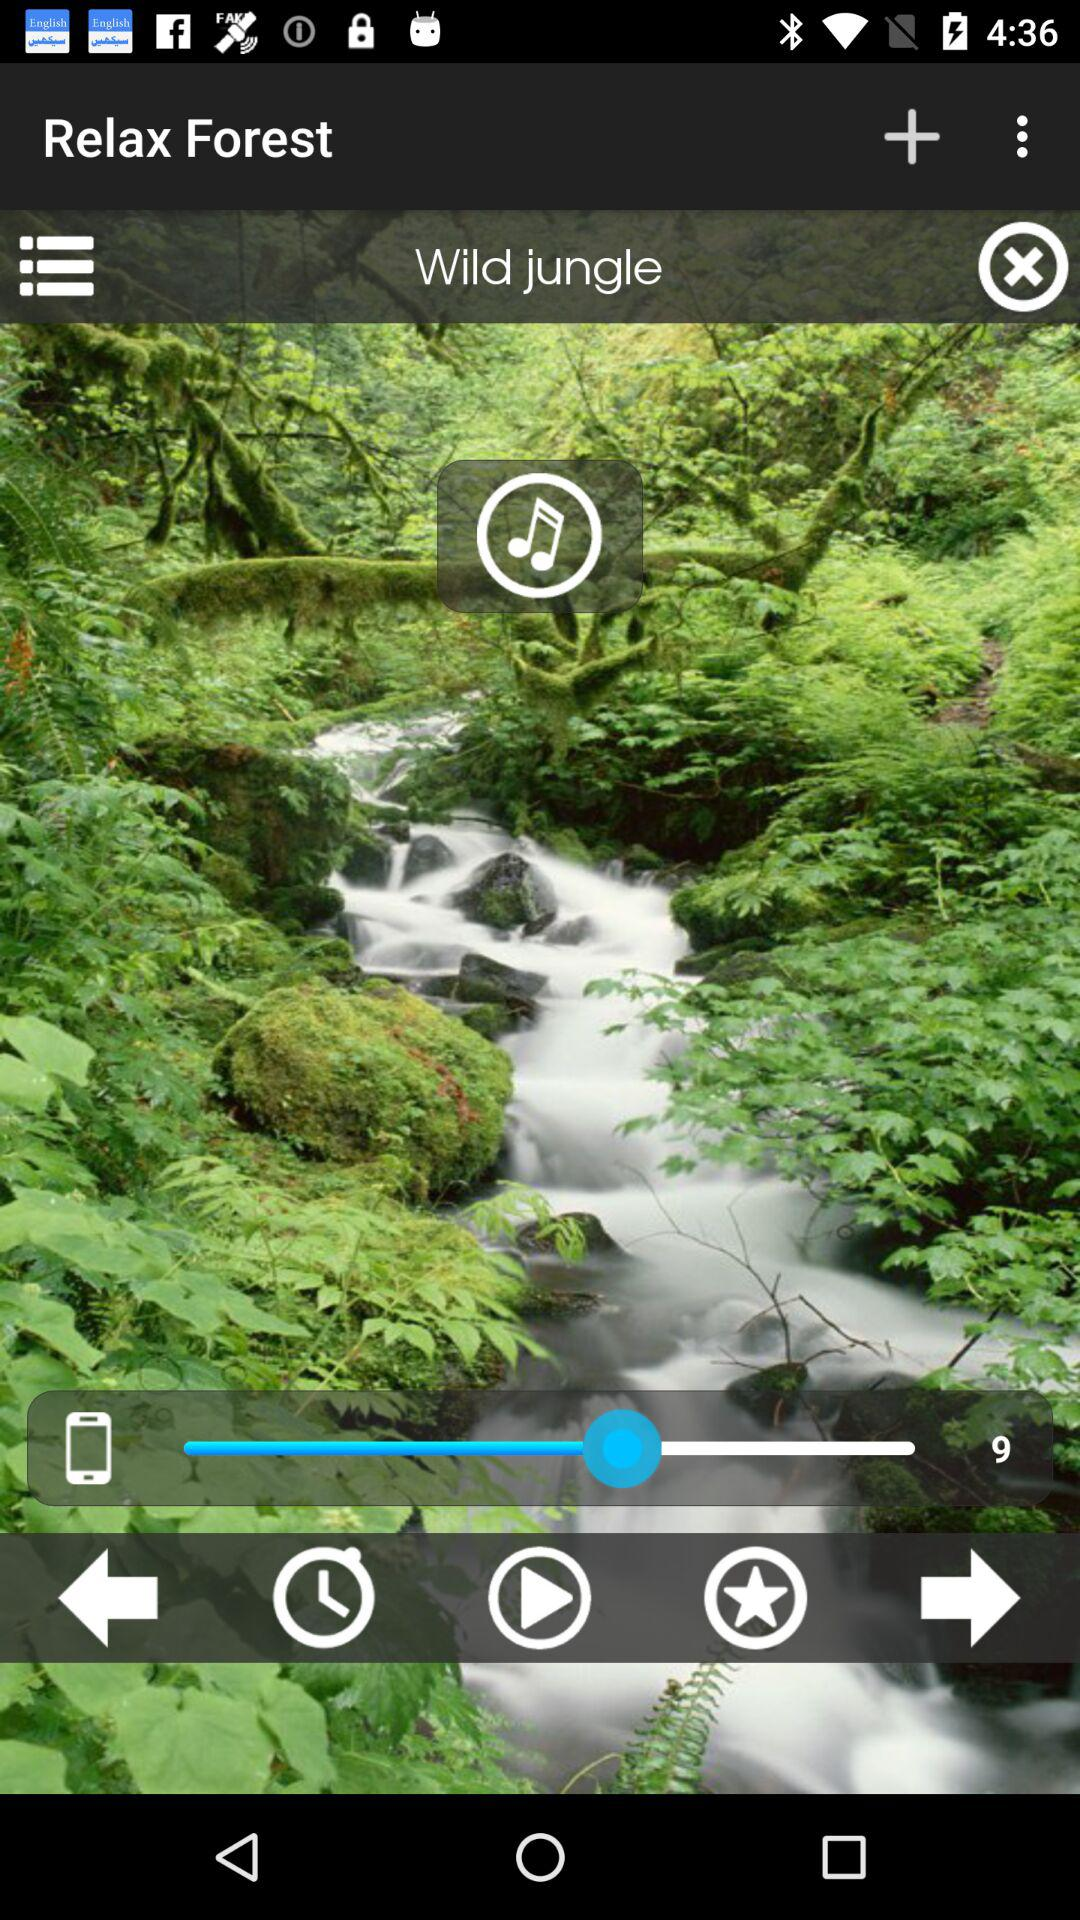What is the name of the music? The name of the music is "Wild jungle". 